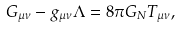<formula> <loc_0><loc_0><loc_500><loc_500>G _ { \mu \nu } - g _ { \mu \nu } \Lambda = 8 \pi G _ { N } T _ { \mu \nu } ,</formula> 